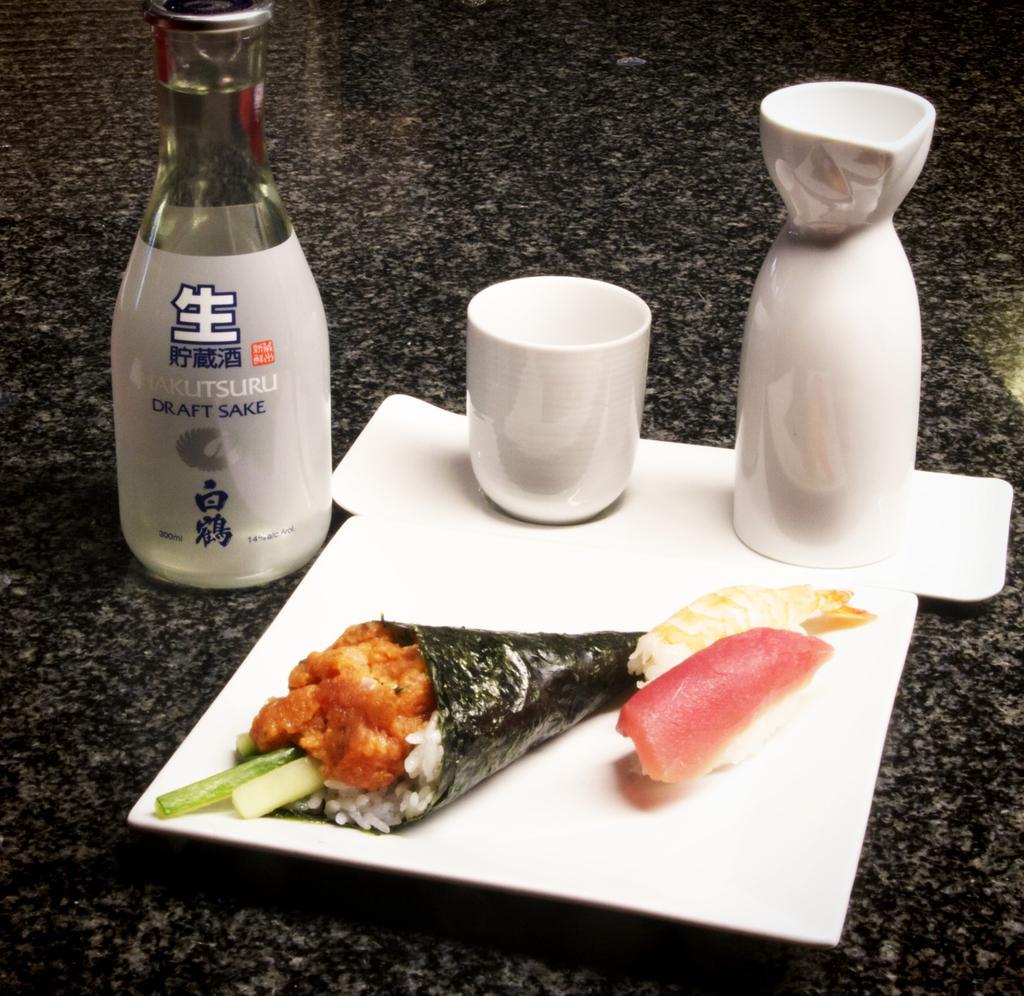In one or two sentences, can you explain what this image depicts? In the middle of the image there is a table on the table there are some bottles and cup and there are some food items. 